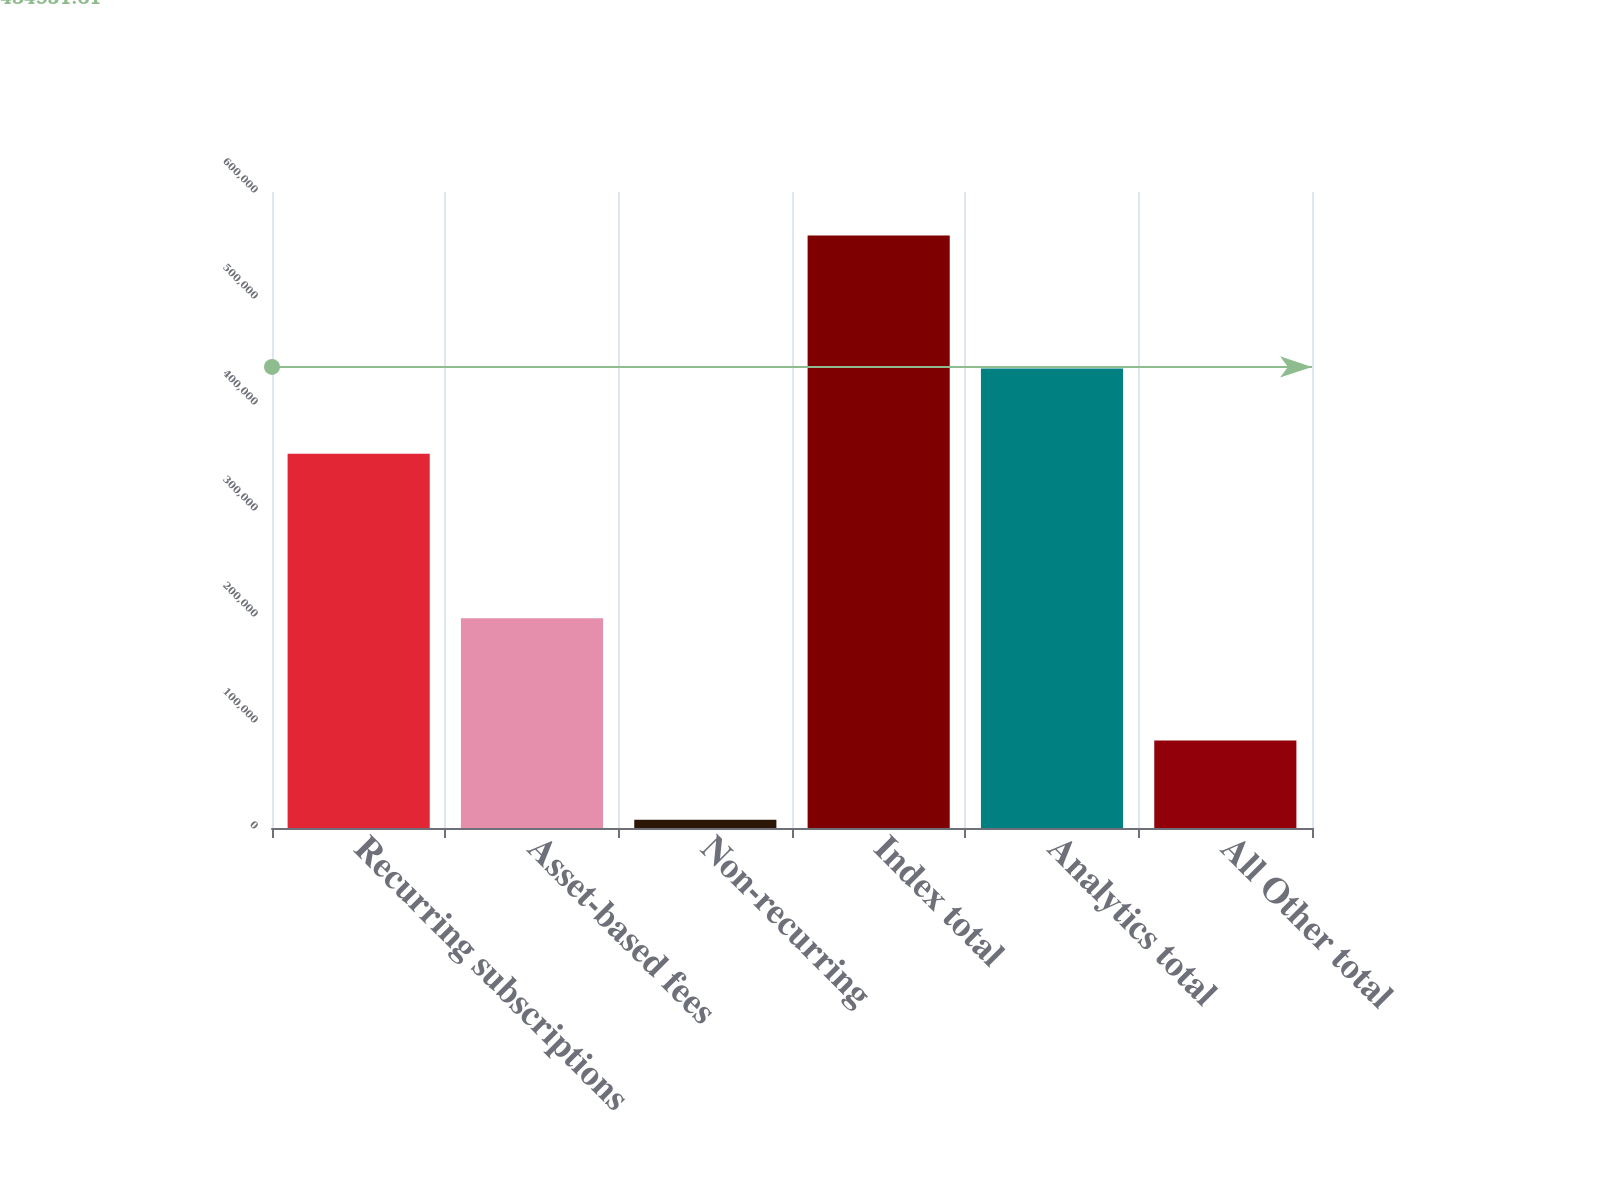<chart> <loc_0><loc_0><loc_500><loc_500><bar_chart><fcel>Recurring subscriptions<fcel>Asset-based fees<fcel>Non-recurring<fcel>Index total<fcel>Analytics total<fcel>All Other total<nl><fcel>353136<fcel>197974<fcel>7854<fcel>558964<fcel>433424<fcel>82625<nl></chart> 